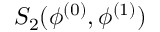<formula> <loc_0><loc_0><loc_500><loc_500>S _ { 2 } ( \phi ^ { ( 0 ) } , \phi ^ { ( 1 ) } )</formula> 